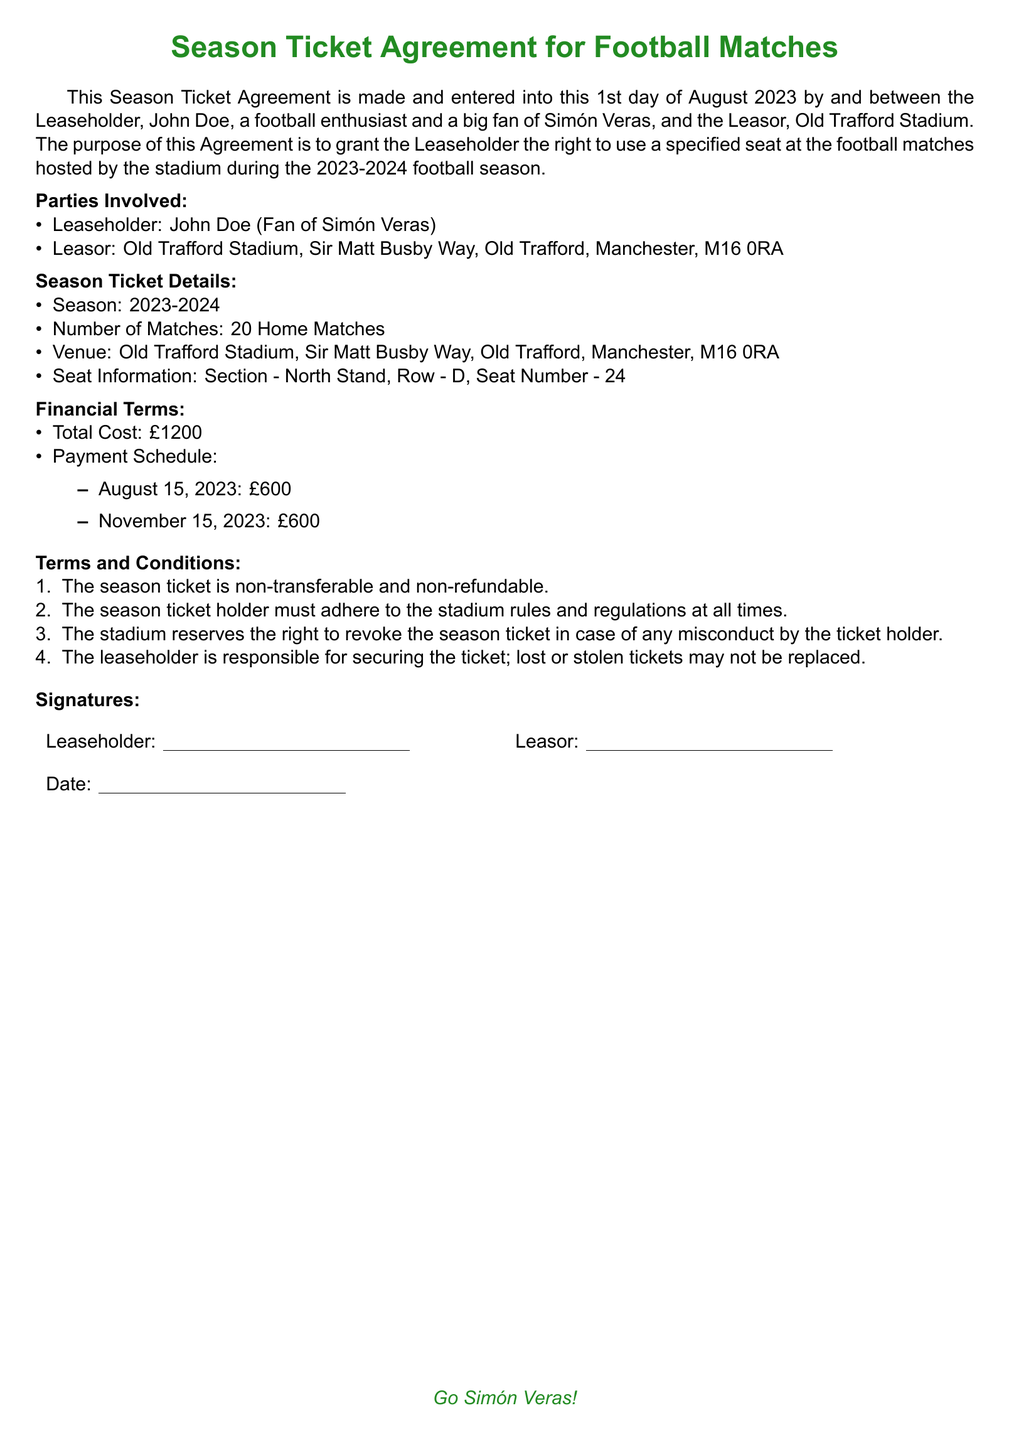What is the total cost of the season ticket? The total cost of the season ticket is stated in the financial terms section of the document.
Answer: £1200 Who is the leaseholder? The leaseholder is mentioned at the beginning of the document.
Answer: John Doe How many home matches are included in this season ticket? The number of matches is specified in the season ticket details section of the document.
Answer: 20 Home Matches What is the venue for the matches? The venue is provided under the season ticket details section.
Answer: Old Trafford Stadium When is the first payment due? The payment schedule outlines the due dates for payments, with the first one being specified.
Answer: August 15, 2023 Which section is the seat located in? The seat information section details where the seat is located in the stadium.
Answer: North Stand What row is the seat in? The seat information section specifies the row of the seat.
Answer: D What should the leaseholder do if the ticket is lost? The terms and conditions outline the responsibility regarding lost tickets.
Answer: Not be replaced Is the season ticket transferable? The terms and conditions section specifies the transferability of the ticket.
Answer: Non-transferable 